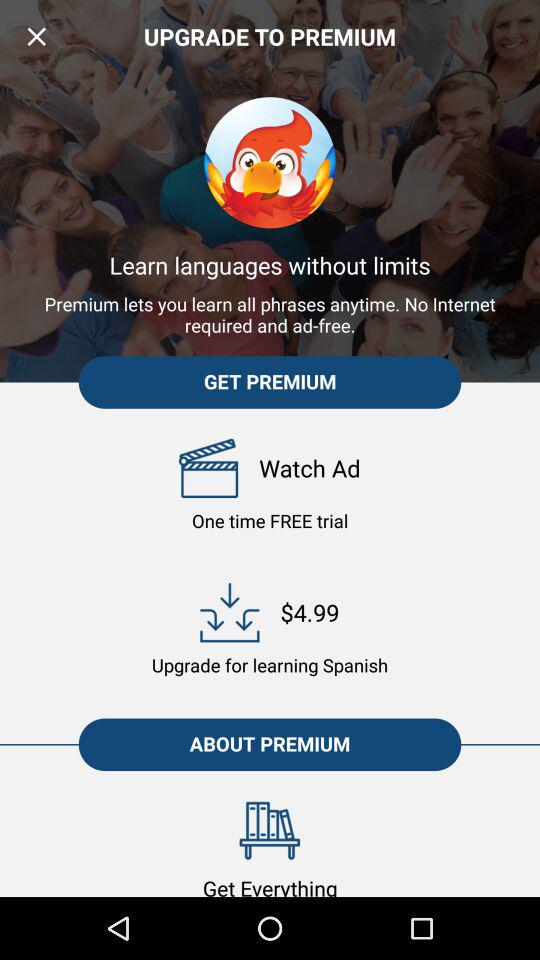How many times is a free trial available? There is a one-time free trial available. 